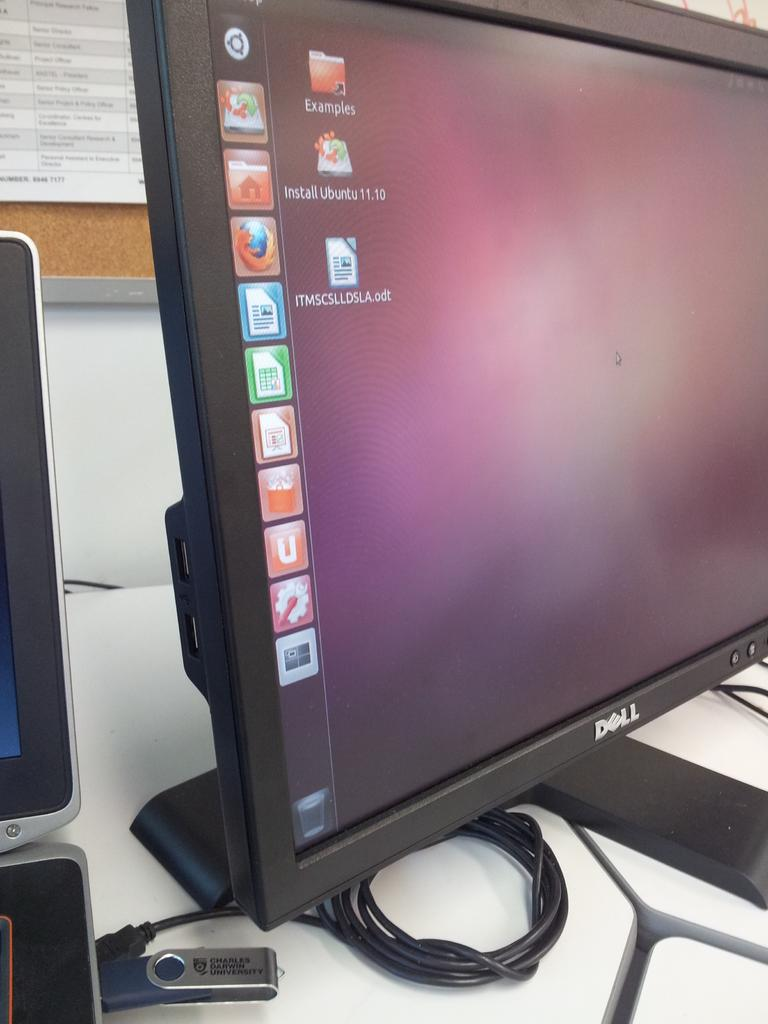<image>
Offer a succinct explanation of the picture presented. A Dell computer monitor is powered on and shows program icons on the screen. 